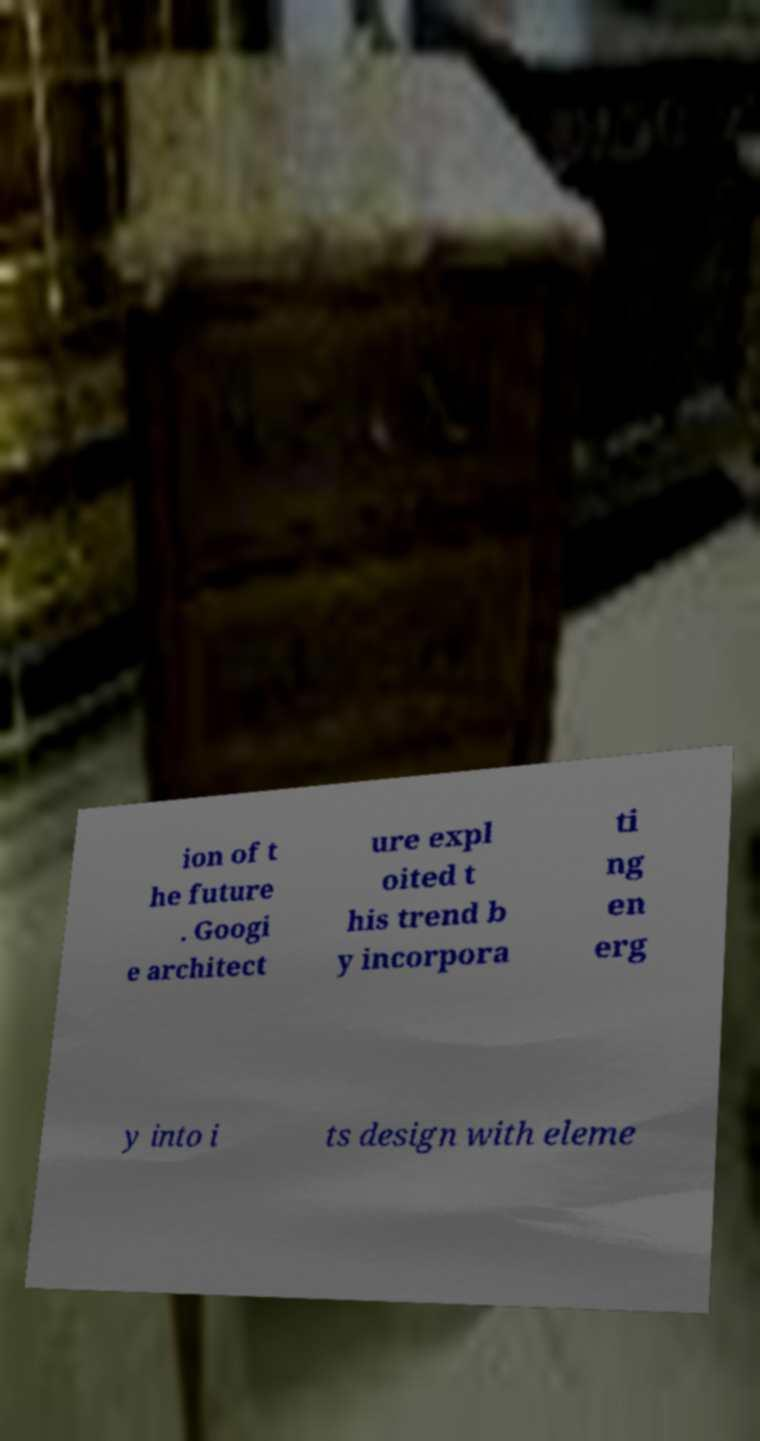Please read and relay the text visible in this image. What does it say? ion of t he future . Googi e architect ure expl oited t his trend b y incorpora ti ng en erg y into i ts design with eleme 